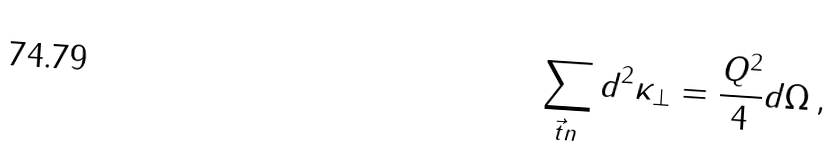<formula> <loc_0><loc_0><loc_500><loc_500>\sum _ { \vec { t } n } d ^ { 2 } \kappa _ { \perp } = \frac { Q ^ { 2 } } { 4 } d \Omega \, ,</formula> 